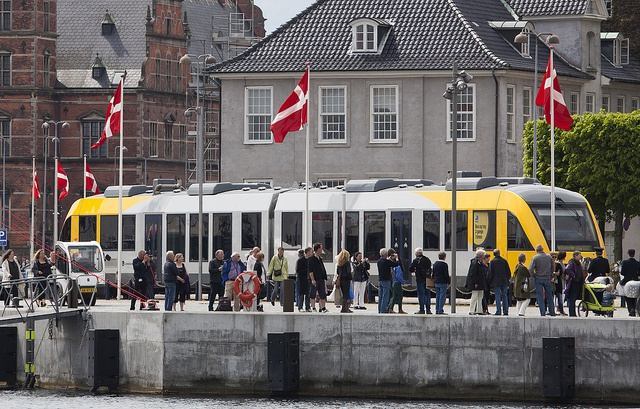Describe the objects in this image and their specific colors. I can see train in gray, lightgray, black, and darkgray tones, bus in gray, lightgray, black, and darkgray tones, people in gray, black, darkgray, and lightgray tones, truck in gray, lightgray, black, and darkgray tones, and people in gray, black, darkgray, and maroon tones in this image. 